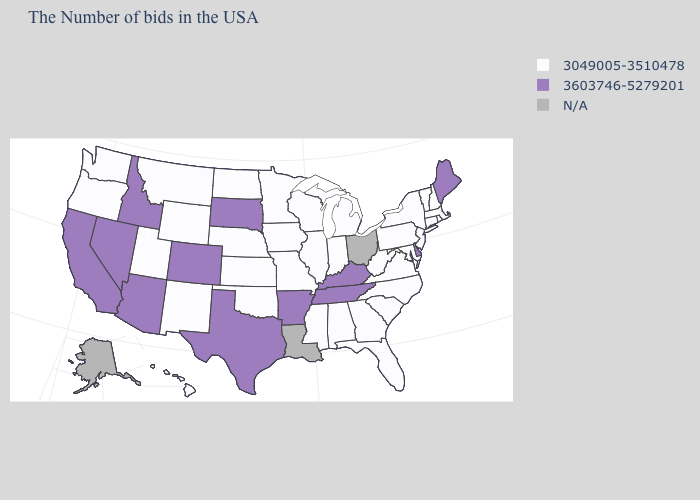Name the states that have a value in the range 3049005-3510478?
Keep it brief. Massachusetts, Rhode Island, New Hampshire, Vermont, Connecticut, New York, New Jersey, Maryland, Pennsylvania, Virginia, North Carolina, South Carolina, West Virginia, Florida, Georgia, Michigan, Indiana, Alabama, Wisconsin, Illinois, Mississippi, Missouri, Minnesota, Iowa, Kansas, Nebraska, Oklahoma, North Dakota, Wyoming, New Mexico, Utah, Montana, Washington, Oregon, Hawaii. Name the states that have a value in the range 3049005-3510478?
Keep it brief. Massachusetts, Rhode Island, New Hampshire, Vermont, Connecticut, New York, New Jersey, Maryland, Pennsylvania, Virginia, North Carolina, South Carolina, West Virginia, Florida, Georgia, Michigan, Indiana, Alabama, Wisconsin, Illinois, Mississippi, Missouri, Minnesota, Iowa, Kansas, Nebraska, Oklahoma, North Dakota, Wyoming, New Mexico, Utah, Montana, Washington, Oregon, Hawaii. How many symbols are there in the legend?
Concise answer only. 3. What is the lowest value in the USA?
Write a very short answer. 3049005-3510478. Which states have the lowest value in the MidWest?
Quick response, please. Michigan, Indiana, Wisconsin, Illinois, Missouri, Minnesota, Iowa, Kansas, Nebraska, North Dakota. Does Florida have the highest value in the USA?
Concise answer only. No. Does Delaware have the highest value in the South?
Concise answer only. Yes. Name the states that have a value in the range 3603746-5279201?
Be succinct. Maine, Delaware, Kentucky, Tennessee, Arkansas, Texas, South Dakota, Colorado, Arizona, Idaho, Nevada, California. Name the states that have a value in the range N/A?
Answer briefly. Ohio, Louisiana, Alaska. Does Mississippi have the lowest value in the USA?
Answer briefly. Yes. Name the states that have a value in the range N/A?
Write a very short answer. Ohio, Louisiana, Alaska. What is the lowest value in the Northeast?
Concise answer only. 3049005-3510478. What is the value of Kentucky?
Give a very brief answer. 3603746-5279201. Name the states that have a value in the range N/A?
Answer briefly. Ohio, Louisiana, Alaska. 